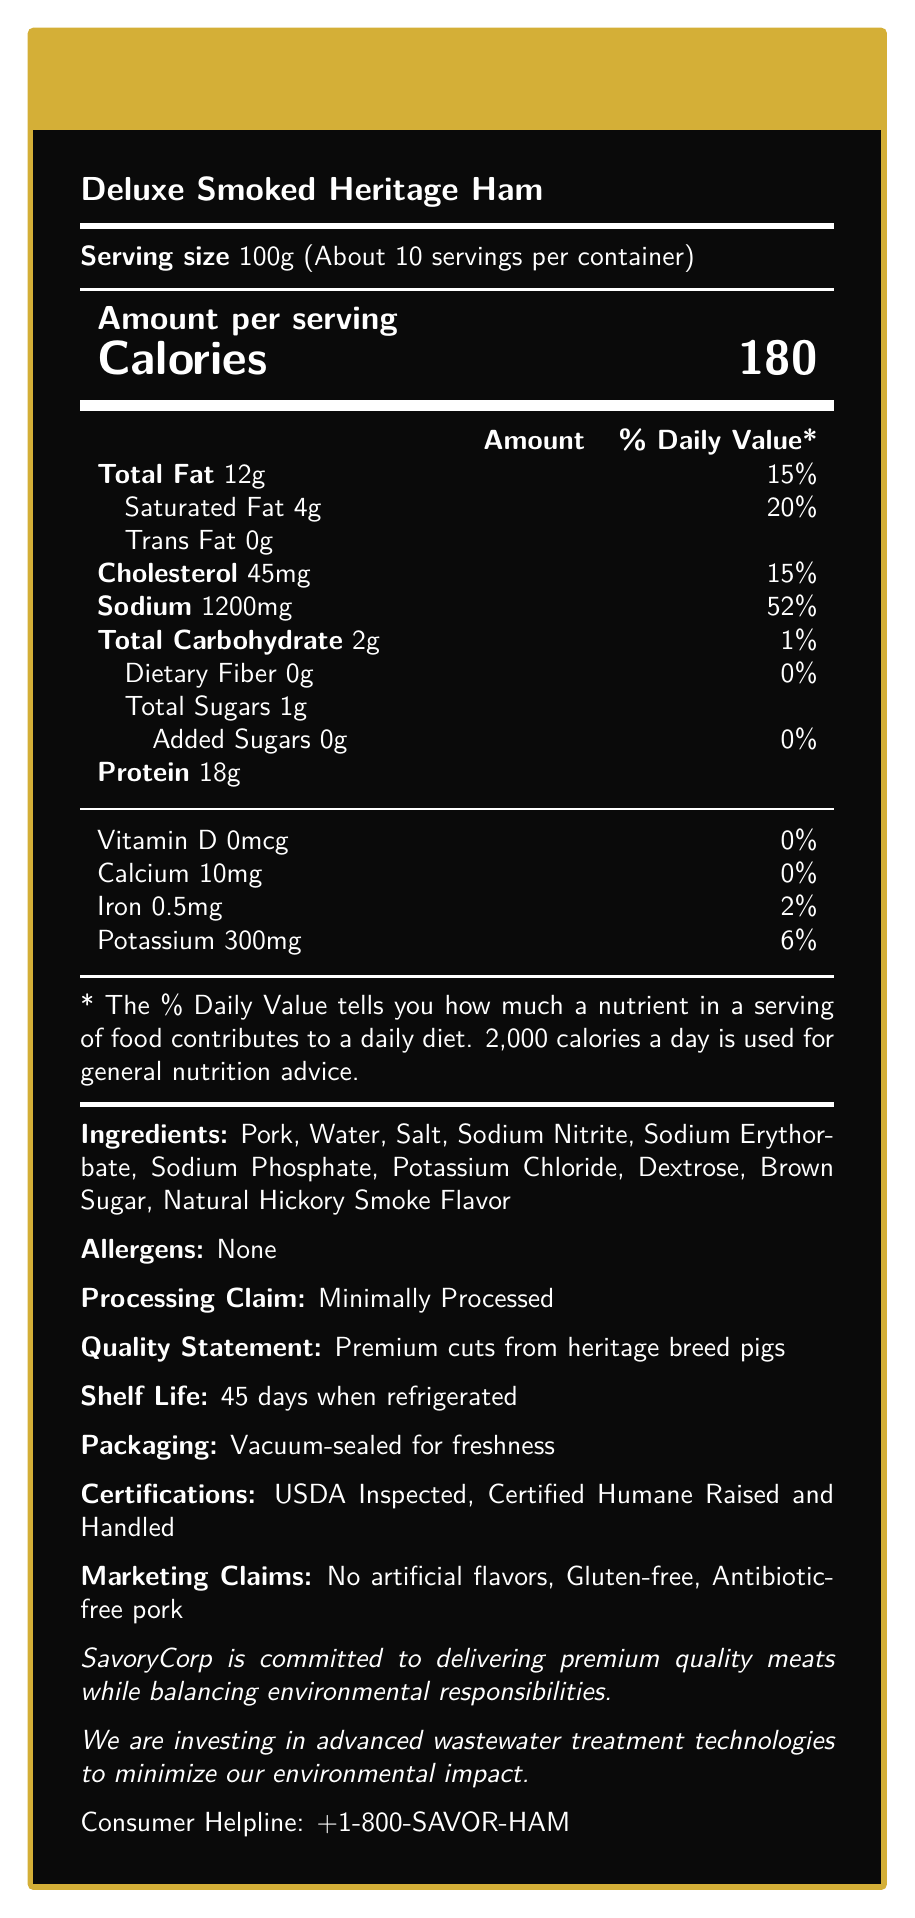what is the serving size? The serving size is clearly listed as 100g in the document.
Answer: 100g how many calories are in one serving? The document specifies that each serving contains 180 calories.
Answer: 180 what percentage of the daily value for sodium is in one serving? The document states that one serving provides 52% of the daily value for sodium.
Answer: 52% name two preservatives mentioned in the document. These preservatives are listed under the ingredients and preservative sections.
Answer: Sodium Nitrite, Sodium Erythorbate what are the two certifications listed on the document? The certifications are explicitly mentioned towards the end of the document.
Answer: USDA Inspected, Certified Humane Raised and Handled what is the total fat content per serving? A. 10g B. 12g C. 15g D. 20g The document lists the total fat content per serving as 12g.
Answer: B how many mg of potassium are in one serving? A. 100mg B. 200mg C. 300mg D. 400mg The document specifies that each serving contains 300mg of potassium.
Answer: C does the product contain any artificial flavors? The document includes the claim "No artificial flavors" in the marketing section.
Answer: No is the product gluten-free? The marketing claims section states that the product is gluten-free.
Answer: Yes summarize the main idea of the document. The document comprehensively covers the key attributes, nutritional content, and various marketing and quality claims for the product, aiming to inform consumers about what they are purchasing.
Answer: The document outlines the nutritional information, ingredients, and various claims for a premium processed meat product called "Deluxe Smoked Heritage Ham." It provides details on serving size, calories, and macronutrients, alongside quality statements, preservative details, and compliance certifications. what is the daily value percentage for dietary fiber? The nutritional facts list the daily value for dietary fiber as 0%.
Answer: 0% what does the processing claim for the product state? The document indicates that the product is marketed as minimally processed.
Answer: Minimally Processed how long is the shelf life of the product when refrigerated? The document specifies a refrigerated shelf life of 45 days.
Answer: 45 days can this document tell you the source of the pork used in the product? The document states that the meat comes from heritage breed pigs but does not specify the geographic or farm source of the pork.
Answer: Not enough information 